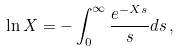<formula> <loc_0><loc_0><loc_500><loc_500>\ln X = - \int _ { 0 } ^ { \infty } \frac { e ^ { - X s } } { s } d s \, ,</formula> 